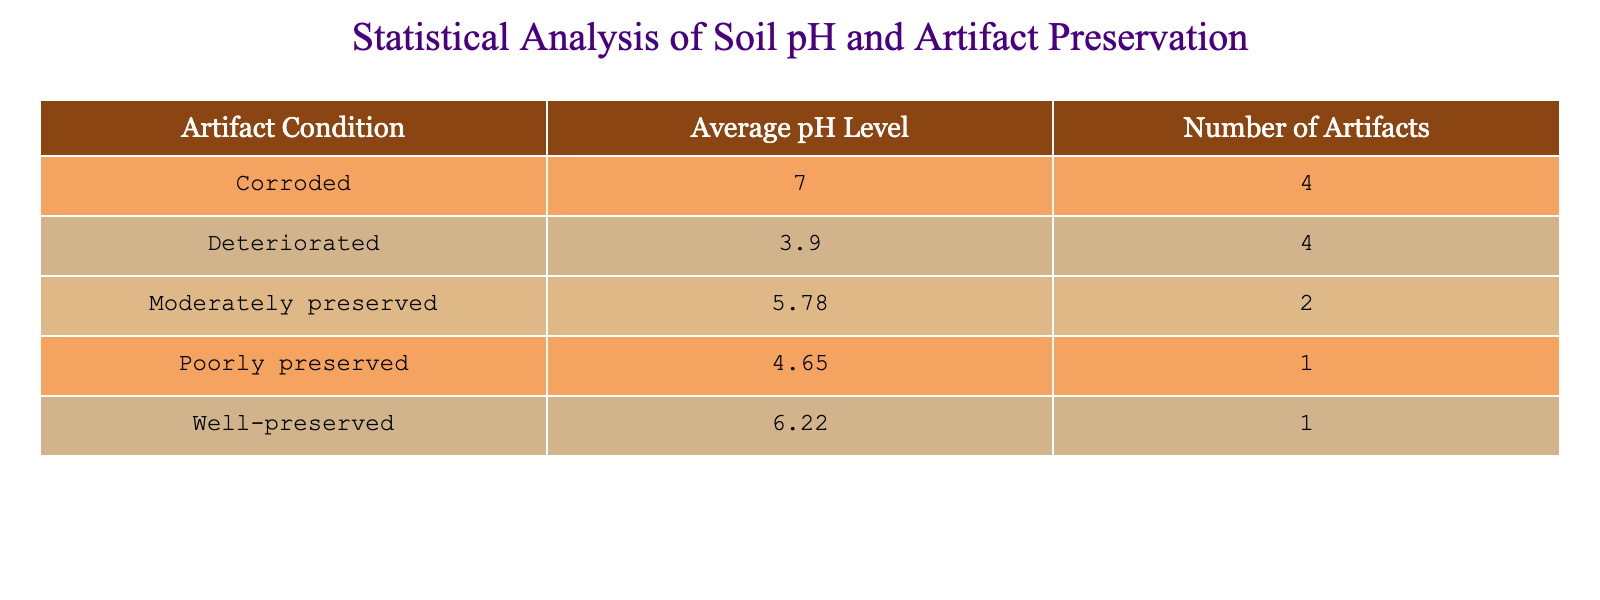What is the average pH level for artifacts in good condition? The table shows the average pH level for each artifact condition. The average pH level for "Well-preserved" artifacts is calculated by taking the average of the pH levels for the relevant samples: (5.2 + 6.5 + 6.9 + 6.3) / 4 = 6.25.
Answer: 6.25 How many artifacts are in the "Poorly preserved" category? The count of artifacts in the "Poorly preserved" category can be directly found in the "Number of Artifacts" column of the table. There are 3 artifacts listed in this category.
Answer: 3 Is there any artifact condition with a pH level higher than 7? By examining the average pH levels, we can see that the maximum pH level recorded in the table is 7.0, which is for "Corroded" artifacts. Since 7.0 is not higher than 7, the answer is no.
Answer: No What is the average pH level for artifacts that are deteriorated? Only one artifact is classified as "Deteriorated," which has a pH level of 3.9. For the average, we take that single value, as there are no other values to average with. Thus, the average pH level for this condition is 3.9.
Answer: 3.9 Which artifact condition has the highest average pH level? The average pH levels for each condition are: Well-preserved (6.25), Moderately preserved (5.83), Poorly preserved (4.97), and Deteriorated (3.9). Among these, "Well-preserved" has the highest average pH level of 6.25.
Answer: Well-preserved What is the difference in the number of artifacts between "Moderately preserved" and "Corroded"? From the table, the number of "Moderately preserved" artifacts is 4, and for "Corroded," it is 1. The difference is calculated as 4 - 1 = 3.
Answer: 3 Does the table show more artifacts in "Well-preserved" condition compared to "Deteriorated"? By checking the number of artifacts, "Well-preserved" has 4 artifacts, while "Deteriorated" has only 1. Therefore, the statement is true as there are more artifacts in "Well-preserved" condition.
Answer: Yes What is the total number of artifacts across all conditions? To find the total number of artifacts, we sum the "Number of Artifacts" for all conditions: 4 (Well-preserved) + 4 (Moderately preserved) + 3 (Poorly preserved) + 1 (Deteriorated) = 12.
Answer: 12 